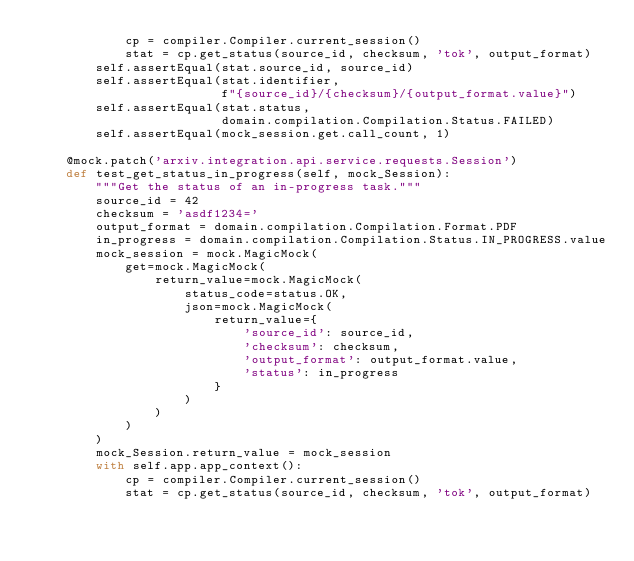<code> <loc_0><loc_0><loc_500><loc_500><_Python_>            cp = compiler.Compiler.current_session()
            stat = cp.get_status(source_id, checksum, 'tok', output_format)
        self.assertEqual(stat.source_id, source_id)
        self.assertEqual(stat.identifier,
                         f"{source_id}/{checksum}/{output_format.value}")
        self.assertEqual(stat.status,
                         domain.compilation.Compilation.Status.FAILED)
        self.assertEqual(mock_session.get.call_count, 1)

    @mock.patch('arxiv.integration.api.service.requests.Session')
    def test_get_status_in_progress(self, mock_Session):
        """Get the status of an in-progress task."""
        source_id = 42
        checksum = 'asdf1234='
        output_format = domain.compilation.Compilation.Format.PDF
        in_progress = domain.compilation.Compilation.Status.IN_PROGRESS.value
        mock_session = mock.MagicMock(
            get=mock.MagicMock(
                return_value=mock.MagicMock(
                    status_code=status.OK,
                    json=mock.MagicMock(
                        return_value={
                            'source_id': source_id,
                            'checksum': checksum,
                            'output_format': output_format.value,
                            'status': in_progress
                        }
                    )
                )
            )
        )
        mock_Session.return_value = mock_session
        with self.app.app_context():
            cp = compiler.Compiler.current_session()
            stat = cp.get_status(source_id, checksum, 'tok', output_format)</code> 